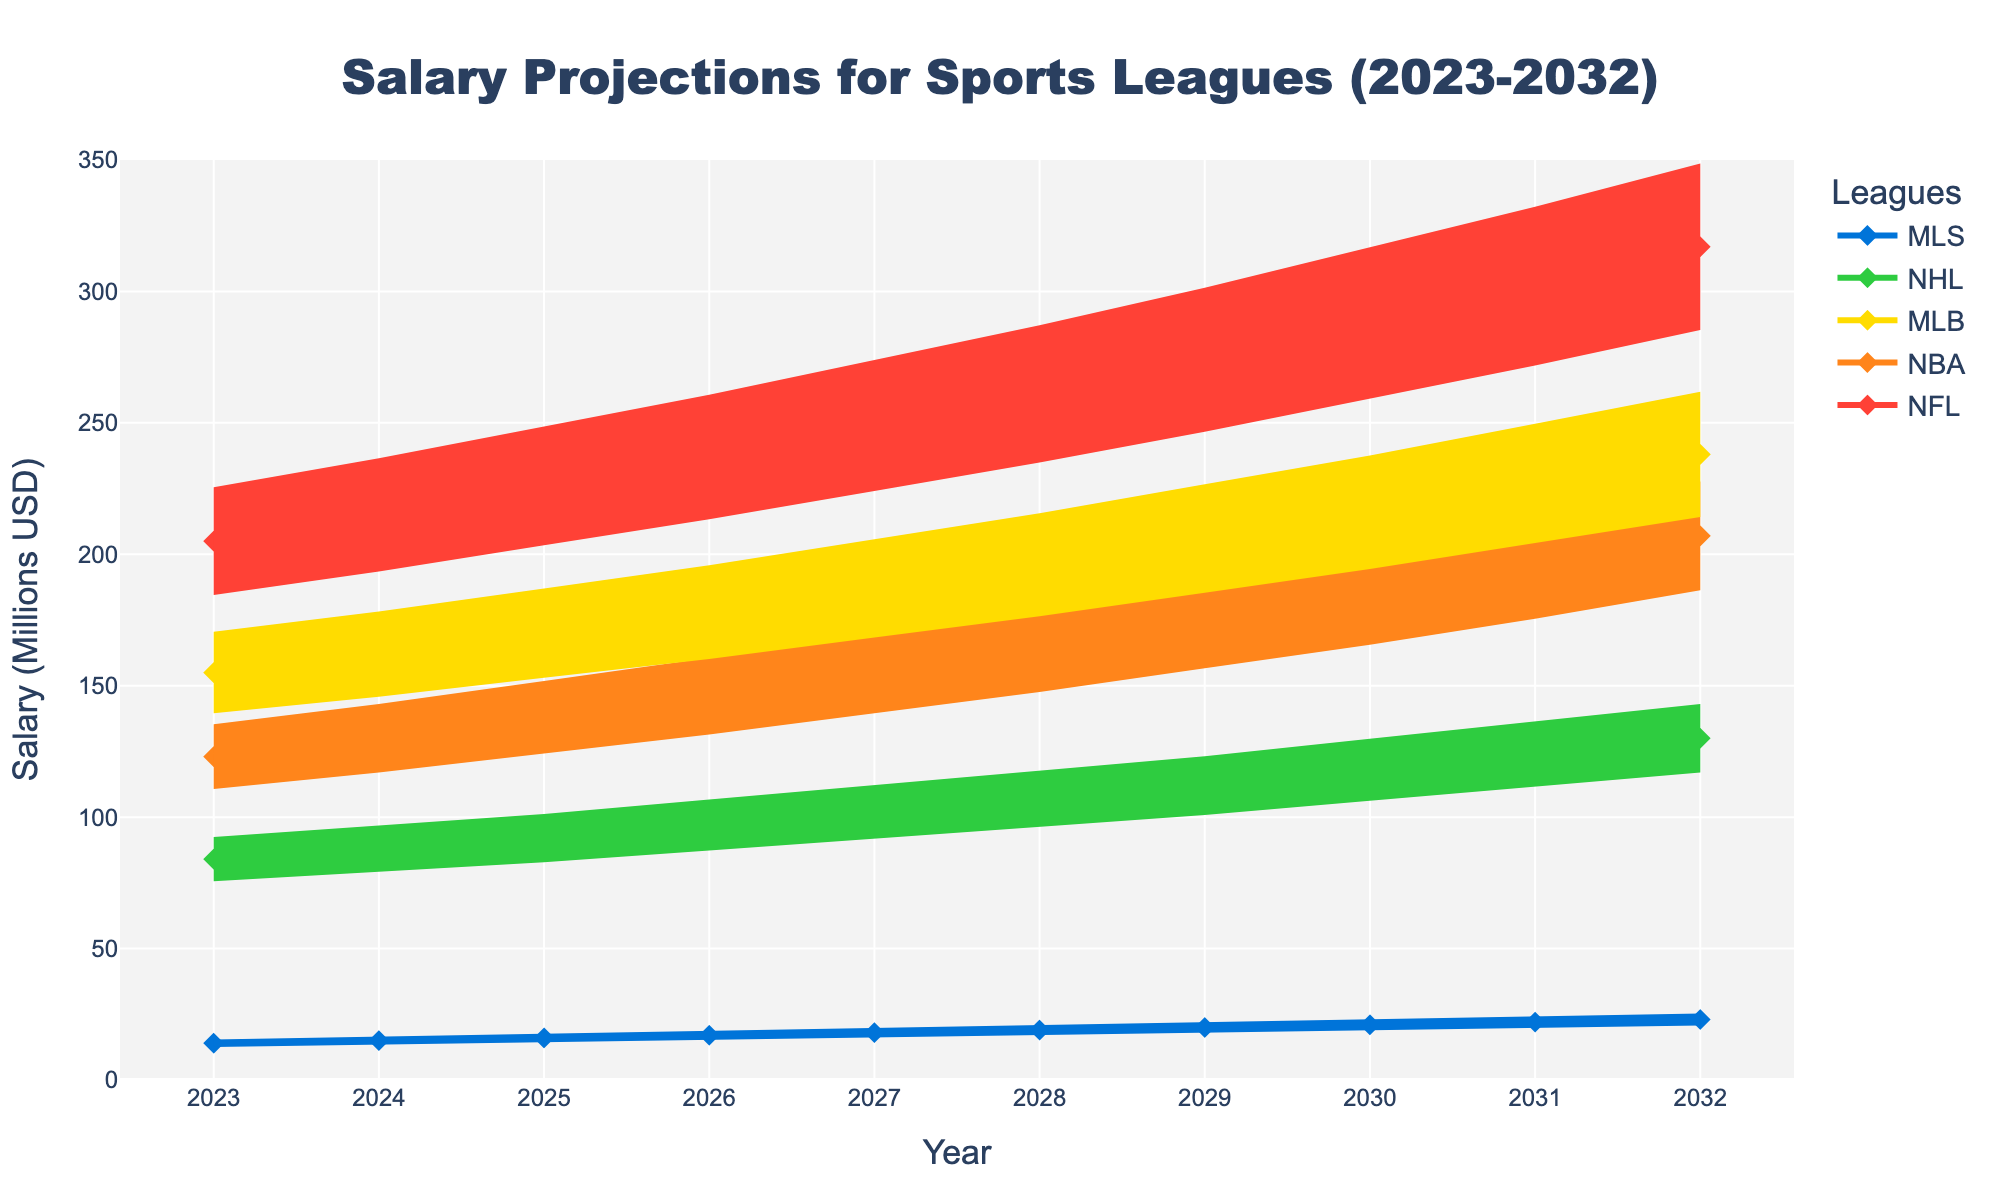What is the title of the chart? The title of the chart is displayed prominently at the top. Looking at the visual information given, the title reads 'Salary Projections for Sports Leagues (2023-2032)'.
Answer: Salary Projections for Sports Leagues (2023-2032) Which league has the highest projected salary in 2026? To determine this, observe the projections for 2026, identify the tallest line or marker. The NFL line reaches the highest value compared to other leagues in 2026.
Answer: NFL By how much is the NBA's salary projected to increase from 2023 to 2024? Examine the point for NBA in 2023 and then in 2024. The salary in 2023 is 123 million USD and in 2024 it is 130 million USD. The increase is calculated as 130 - 123 = 7 million USD.
Answer: 7 million USD What is the range of salary projections for the MLS in 2030? For the range, identify the upper and lower bounds around the projection for MLS in 2030. The projection is 21 million USD. Using a 10% fluctuation, the range is 21 +/- 2.1, i.e., between 18.9 million and 23.1 million USD.
Answer: 18.9 million USD to 23.1 million USD Which league has the smallest projected salary in 2032? Look at the salaries projected for all leagues in 2032. The MLS has the smallest projected salary compared to the NFL, NBA, MLB, and NHL.
Answer: MLS By how much is the MLB's salary projected to change from 2028 to 2031? Locate the MLB's projected salary for 2028 and 2031. The values are 196 million USD in 2028 and 227 million USD in 2031. The change is calculated as 227 - 196 = 31 million USD.
Answer: 31 million USD Between which two consecutive years does the NFL show the largest growth in salary projections? Check the NFL's salary figures between consecutive years. The largest growth can be observed between 2029 and 2030, where it goes from 274 million USD to 288 million USD, providing a 14 million USD increase.
Answer: 2029 to 2030 Does any league exhibit a linear growth in salary projections? Examine each league’s growth pattern. The projections for all leagues increase consistently each year, suggesting linear growth patterns.
Answer: Yes How does the salary projection trend for the NHL compare to the NBA from 2023 to 2032? Observe the lines for both NHL and NBA from 2023 to 2032. Both exhibit upward trends, but the NBA maintains a higher salary projection throughout the period.
Answer: NBA has higher projections throughout What are the upper and lower bounds of the NFL's projected salary in 2027? Identify the NFL projection for 2027, which is 249 million USD. The range is calculated as 249 * 1.1 = 273.9 million USD (upper) and 249 * 0.9 = 224.1 million USD (lower).
Answer: 224.1 million USD to 273.9 million USD 